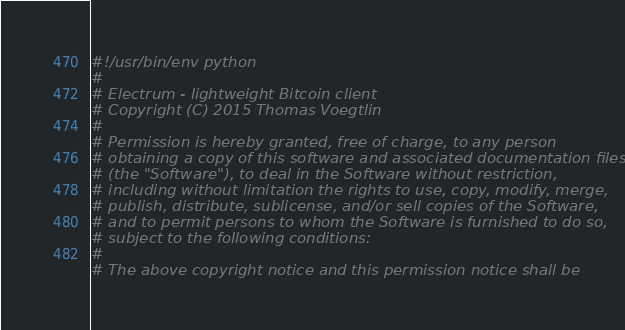<code> <loc_0><loc_0><loc_500><loc_500><_Python_>#!/usr/bin/env python
#
# Electrum - lightweight Bitcoin client
# Copyright (C) 2015 Thomas Voegtlin
#
# Permission is hereby granted, free of charge, to any person
# obtaining a copy of this software and associated documentation files
# (the "Software"), to deal in the Software without restriction,
# including without limitation the rights to use, copy, modify, merge,
# publish, distribute, sublicense, and/or sell copies of the Software,
# and to permit persons to whom the Software is furnished to do so,
# subject to the following conditions:
#
# The above copyright notice and this permission notice shall be</code> 